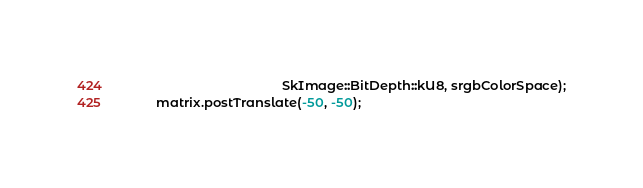<code> <loc_0><loc_0><loc_500><loc_500><_C++_>                                           SkImage::BitDepth::kU8, srgbColorSpace);
        matrix.postTranslate(-50, -50);</code> 